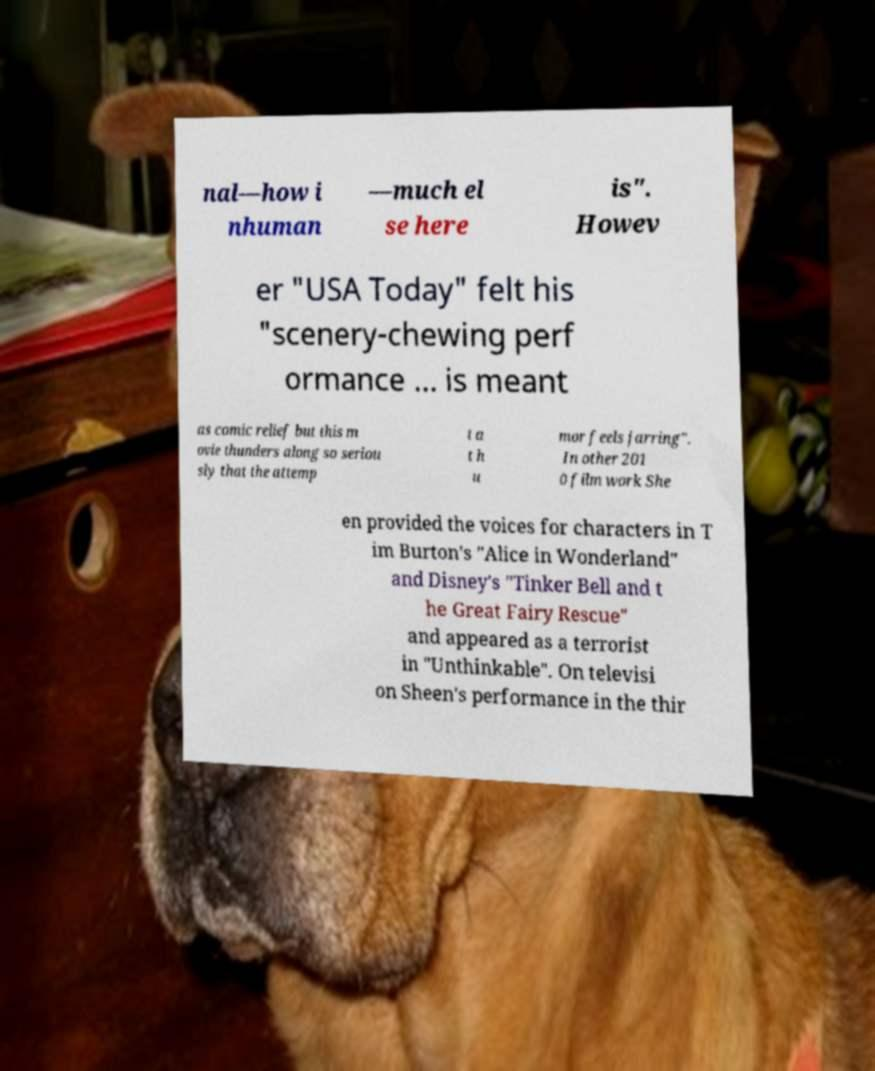Please read and relay the text visible in this image. What does it say? nal—how i nhuman —much el se here is". Howev er "USA Today" felt his "scenery-chewing perf ormance ... is meant as comic relief but this m ovie thunders along so seriou sly that the attemp t a t h u mor feels jarring". In other 201 0 film work She en provided the voices for characters in T im Burton's "Alice in Wonderland" and Disney's "Tinker Bell and t he Great Fairy Rescue" and appeared as a terrorist in "Unthinkable". On televisi on Sheen's performance in the thir 